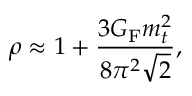<formula> <loc_0><loc_0><loc_500><loc_500>\rho \approx 1 + \frac { 3 G _ { F } m _ { t } ^ { 2 } } { 8 \pi ^ { 2 } \sqrt { 2 } } ,</formula> 